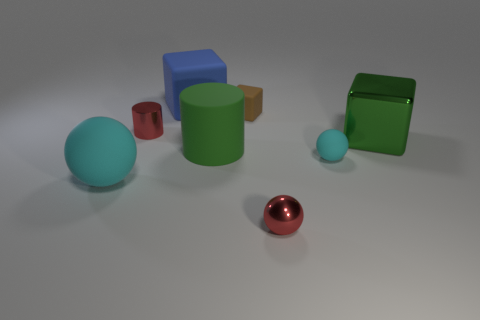The red object left of the small red object that is to the right of the metal cylinder is made of what material? The red object positioned to the left of the smaller red object, which in turn is to the right of the metal cylinder, appears to be made of a glossy material similar to the smaller red object, likely a type of polished metal or plastic with a metallic finish. 